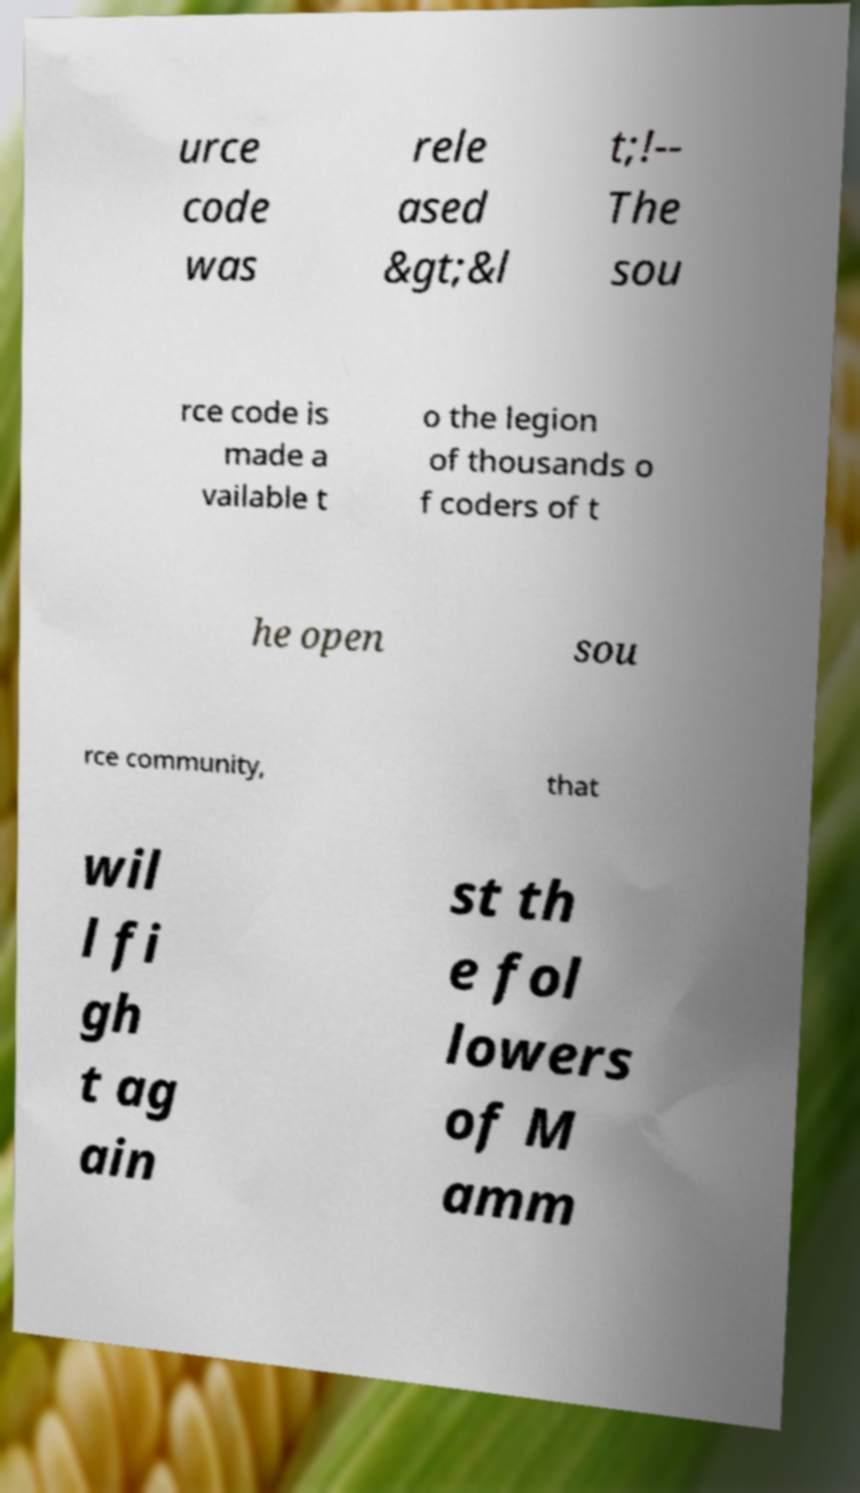Can you read and provide the text displayed in the image?This photo seems to have some interesting text. Can you extract and type it out for me? urce code was rele ased &gt;&l t;!-- The sou rce code is made a vailable t o the legion of thousands o f coders of t he open sou rce community, that wil l fi gh t ag ain st th e fol lowers of M amm 